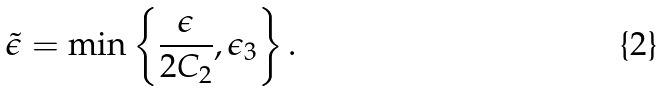Convert formula to latex. <formula><loc_0><loc_0><loc_500><loc_500>\tilde { \epsilon } = \min \left \{ \frac { \epsilon } { 2 C _ { 2 } } , \epsilon _ { 3 } \right \} .</formula> 